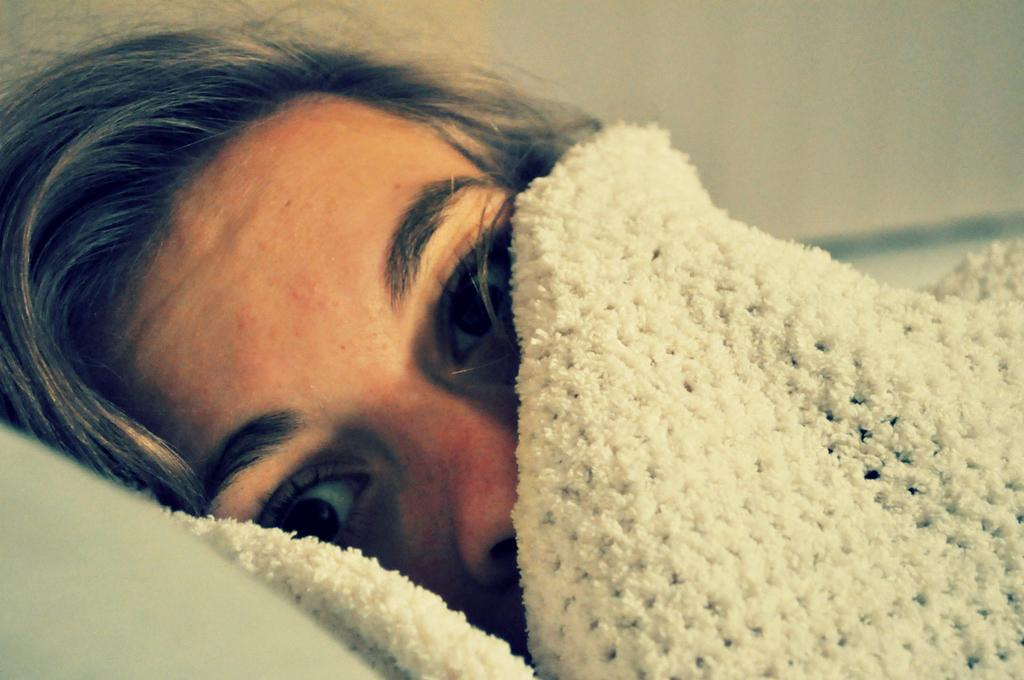What is the position of the person in the image? There is a person lying in the image. What is covering part of the person's face? The person's face is partially covered with a white cloth. What is supporting the person's head? The person's head is resting on a pillow. Can you describe the background of the image? The background of the image is blurred. What type of animal is hopping around the person in the image? There is no animal present in the image; it only features a person lying down with their face partially covered by a white cloth and their head resting on a pillow. 